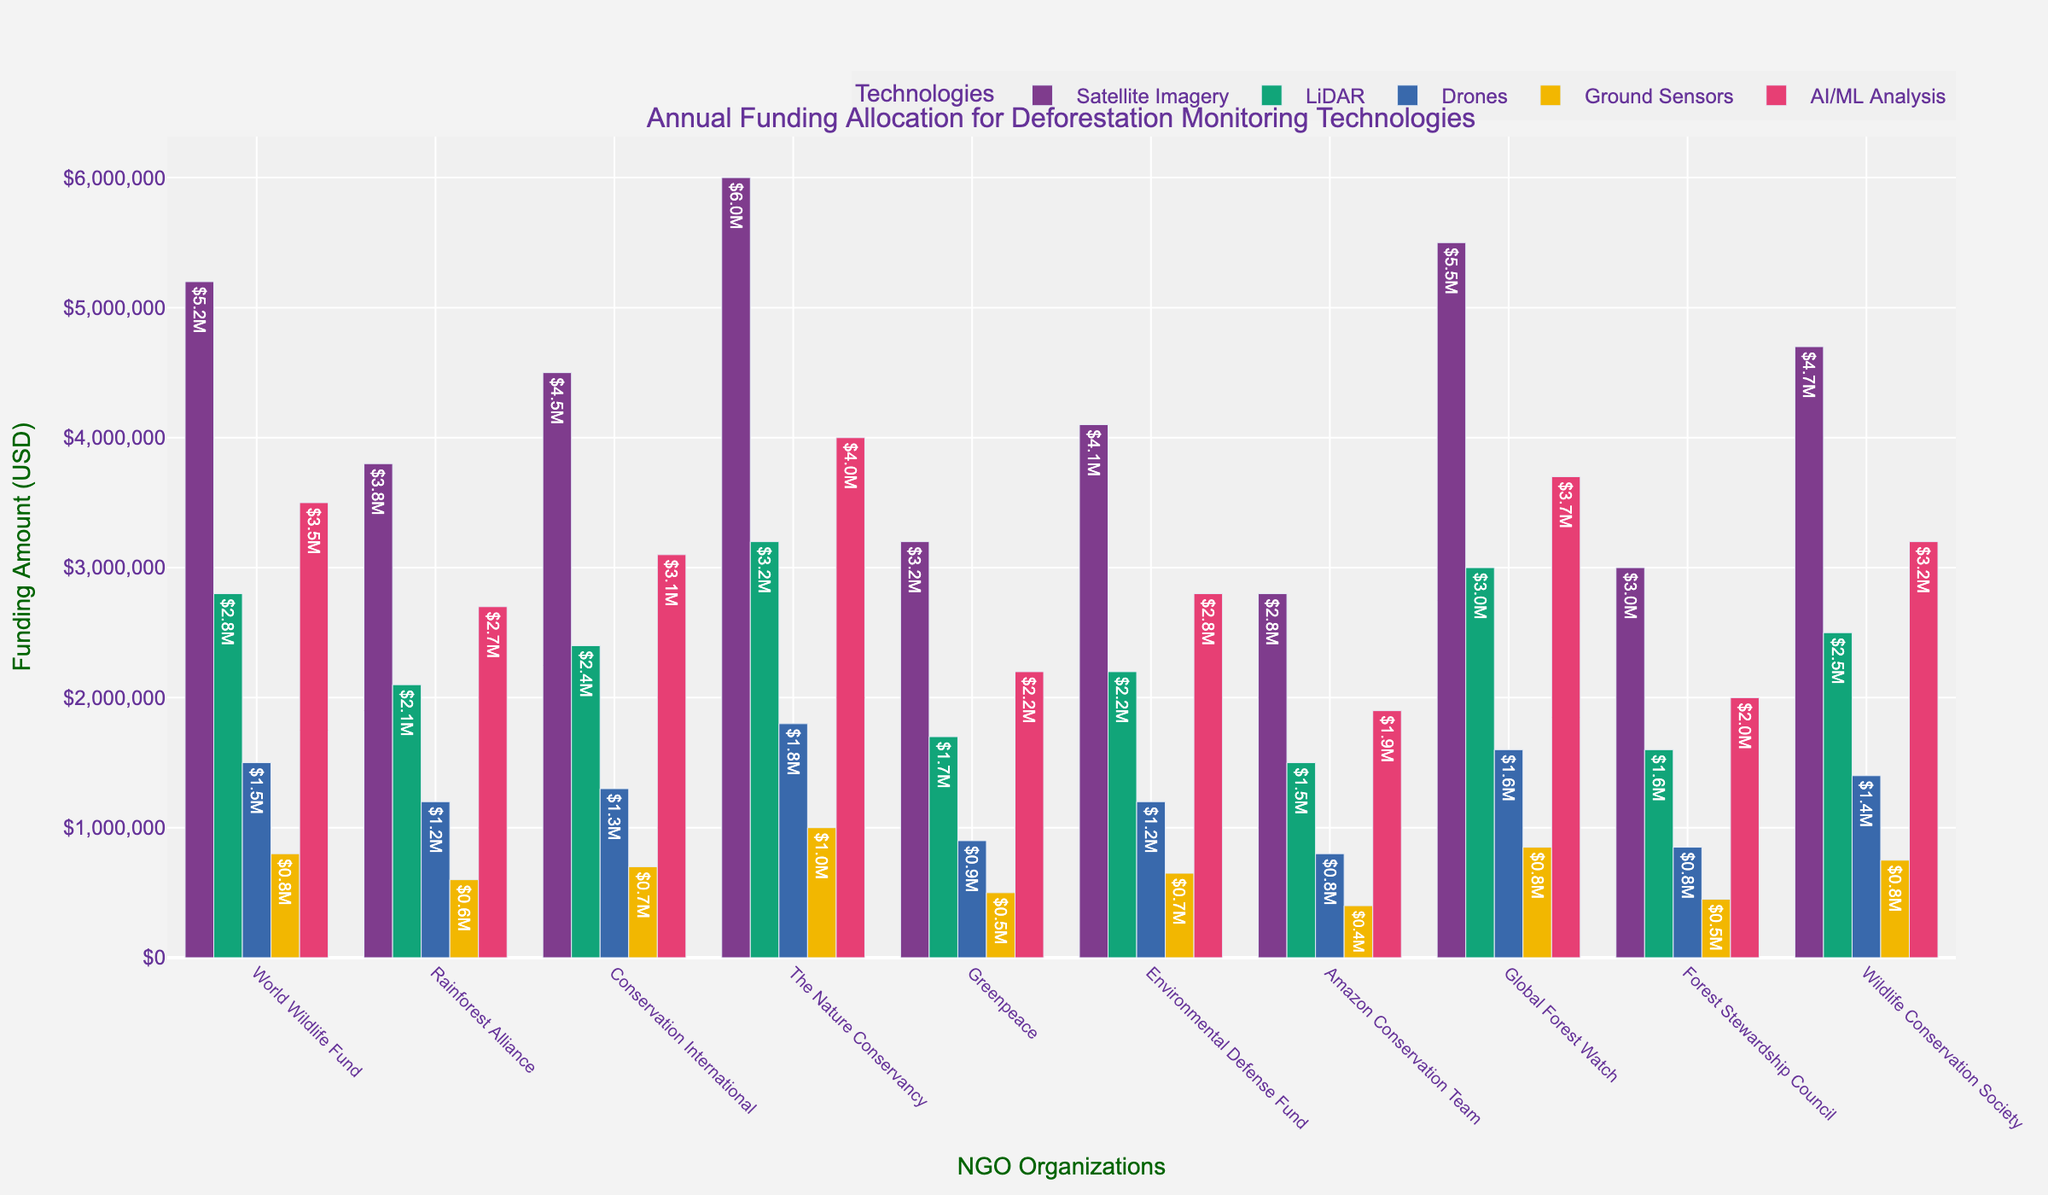What is the total amount of funding allocated by the World Wildlife Fund for all technologies? To find the total amount of funding allocated by the World Wildlife Fund for all technologies, sum up their funding figures: $5,200,000 (Satellite Imagery) + $2,800,000 (LiDAR) + $1,500,000 (Drones) + $800,000 (Ground Sensors) + $3,500,000 (AI/ML Analysis) = $13,800,000
Answer: $13,800,000 Which organization has allocated the highest amount of funding for Satellite Imagery? By visually examining the heights of the bars for Satellite Imagery funding, the tallest bar corresponds to The Nature Conservancy with a funding amount of $6,000,000
Answer: The Nature Conservancy Compare the amount of funding for AI/ML Analysis by Greenpeace and Forest Stewardship Council. Which organization allocated more, and by how much? Greenpeace has allocated $2,200,000 for AI/ML Analysis and Forest Stewardship Council has allocated $2,000,000. The difference is $2,200,000 - $2,000,000 = $200,000
Answer: Greenpeace by $200,000 What is the average funding amount for Drones across all organizations? Sum up the funding amounts for Drones across all organizations: $1,500,000 (World Wildlife Fund) + $1,200,000 (Rainforest Alliance) + $1,300,000 (Conservation International) + $1,800,000 (The Nature Conservancy) + $900,000 (Greenpeace) + $1,200,000 (Environmental Defense Fund) + $800,000 (Amazon Conservation Team) + $1,600,000 (Global Forest Watch) + $850,000 (Forest Stewardship Council) + $1,400,000 (Wildlife Conservation Society) equals $12,350,000. Divide this by the number of organizations (10): $12,350,000 / 10 = $1,235,000
Answer: $1,235,000 Which technology has the least amount of total funding across all organizations? Sum up the funding for each technology across all organizations: Satellite Imagery = $42,000,000, LiDAR = $22,600,000, Drones = $12,350,000, Ground Sensors = $6,900,000, AI/ML Analysis = $28,400,000. The least amount is $6,900,000 for Ground Sensors
Answer: Ground Sensors What is the difference in funding for LiDAR between World Wildlife Fund and Conservation International? World Wildlife Fund has allocated $2,800,000 for LiDAR and Conservation International has allocated $2,400,000. The difference is $2,800,000 - $2,400,000 = $400,000
Answer: $400,000 How much total funding is allocated by Global Forest Watch for all technologies? Sum up the funding allocated by Global Forest Watch for all technologies: $5,500,000 (Satellite Imagery) + $3,000,000 (LiDAR) + $1,600,000 (Drones) + $850,000 (Ground Sensors) + $3,700,000 (AI/ML Analysis) = $14,650,000
Answer: $14,650,000 Which technology receives the highest funding from Conservation International? By examining the heights of the bars for Conservation International, the tallest bar corresponds to Satellite Imagery with a funding amount of $4,500,000
Answer: Satellite Imagery 